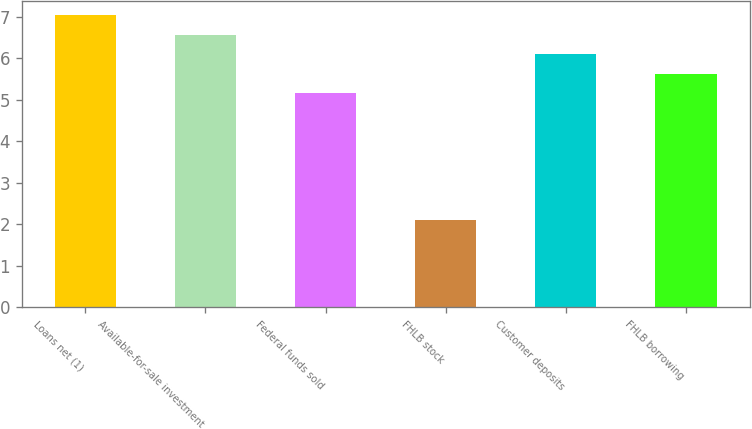Convert chart to OTSL. <chart><loc_0><loc_0><loc_500><loc_500><bar_chart><fcel>Loans net (1)<fcel>Available-for-sale investment<fcel>Federal funds sold<fcel>FHLB stock<fcel>Customer deposits<fcel>FHLB borrowing<nl><fcel>7.04<fcel>6.57<fcel>5.16<fcel>2.11<fcel>6.1<fcel>5.63<nl></chart> 